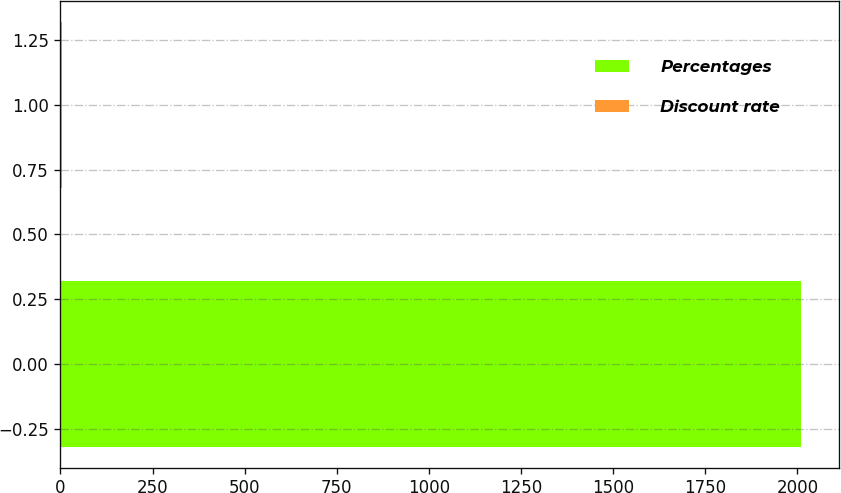Convert chart. <chart><loc_0><loc_0><loc_500><loc_500><bar_chart><fcel>Percentages<fcel>Discount rate<nl><fcel>2011<fcel>5.01<nl></chart> 